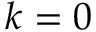Convert formula to latex. <formula><loc_0><loc_0><loc_500><loc_500>k = 0</formula> 